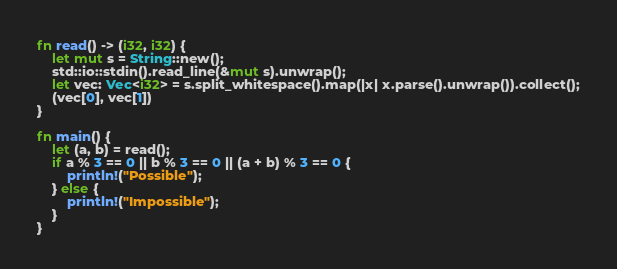Convert code to text. <code><loc_0><loc_0><loc_500><loc_500><_Rust_>fn read() -> (i32, i32) {
    let mut s = String::new();
    std::io::stdin().read_line(&mut s).unwrap();
    let vec: Vec<i32> = s.split_whitespace().map(|x| x.parse().unwrap()).collect();
    (vec[0], vec[1])
}

fn main() {
    let (a, b) = read();
    if a % 3 == 0 || b % 3 == 0 || (a + b) % 3 == 0 {
        println!("Possible");
    } else {
        println!("Impossible");
    }
}
</code> 